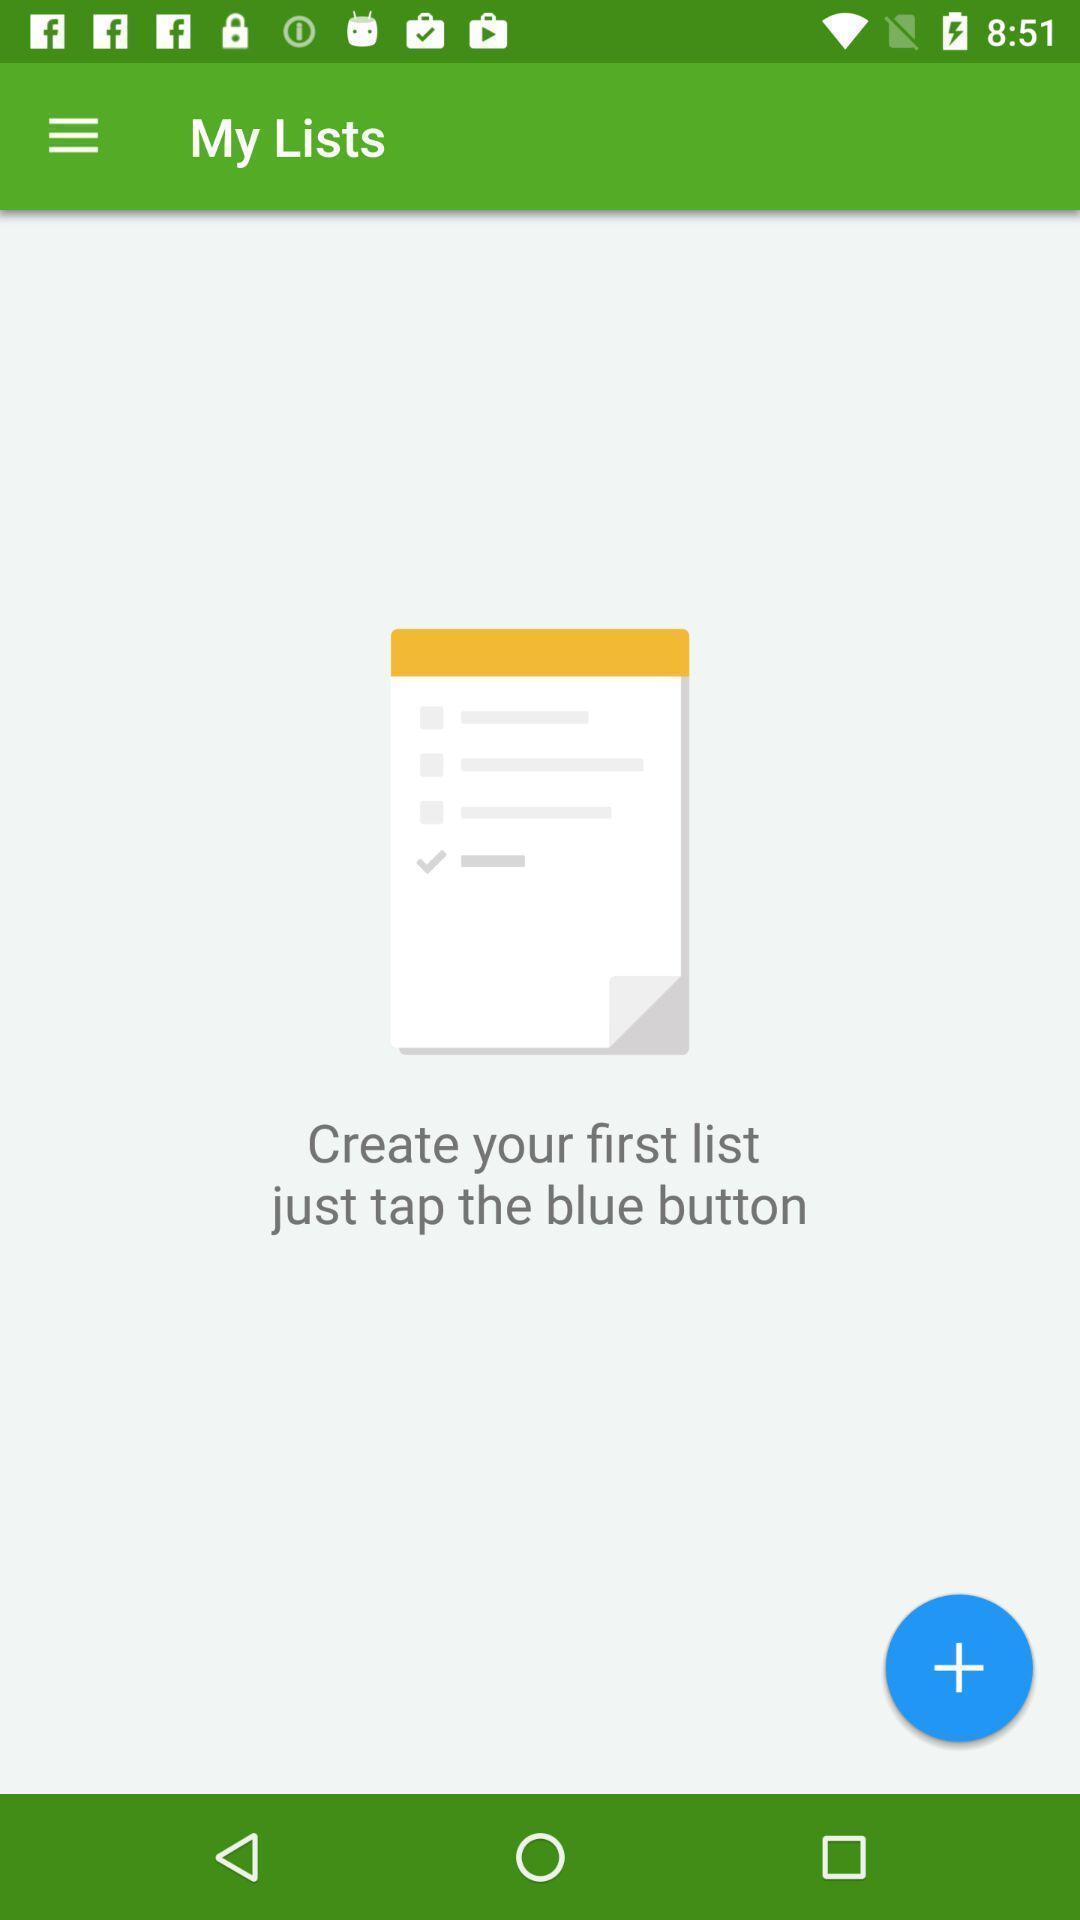What details can you identify in this image? Screen shows create lists page in shopping app. 